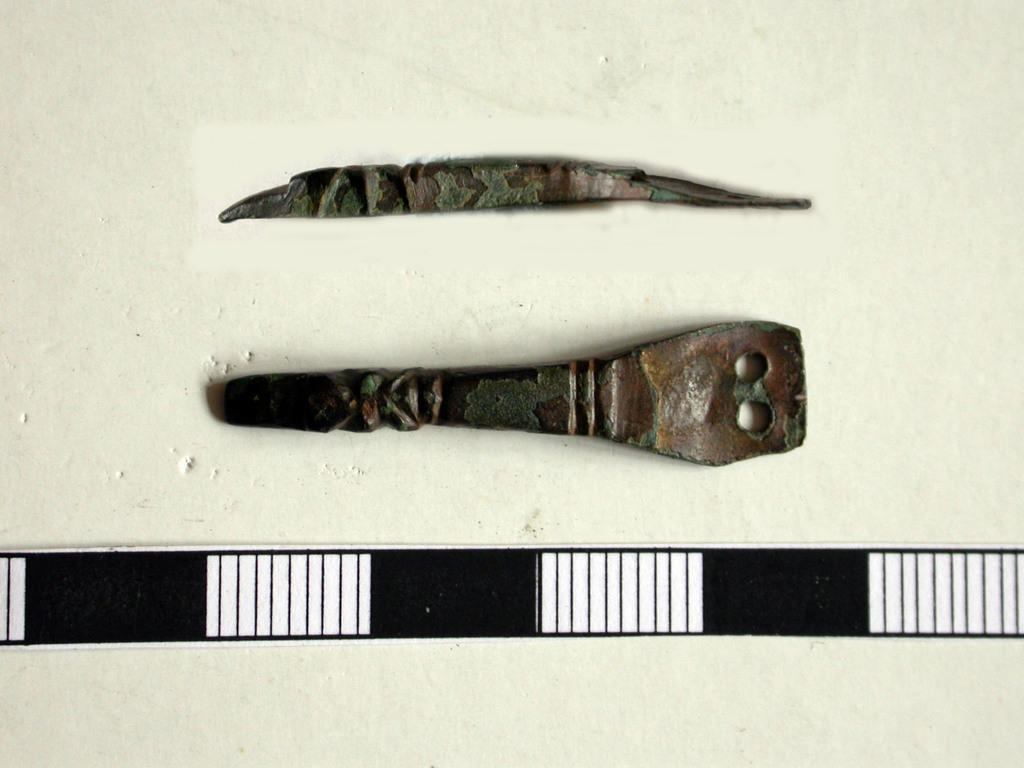What type of objects are present in the image? There are two metal objects in the image. What can be inferred about the nature of these metal objects? The metal objects look like tools. Where is one of the metal objects located in the image? One of the metal objects is at the bottom of the image. What color is the background of the image? The background of the image is white. What type of zebra can be seen walking on the sidewalk in the image? There is no zebra or sidewalk present in the image; it features two metal objects and a white background. Is the image taken during the winter season? The provided facts do not mention any seasonal context, so it cannot be determined if the image was taken during winter. 